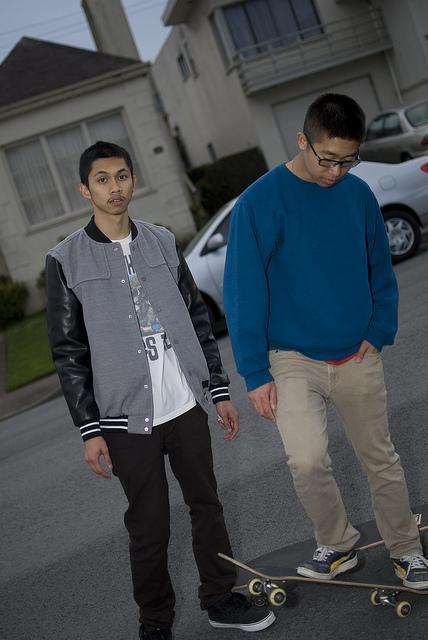How many cars are there?
Give a very brief answer. 2. How many children are seen?
Give a very brief answer. 2. How many skateboards can you see?
Give a very brief answer. 2. How many cars can you see?
Give a very brief answer. 2. How many people can you see?
Give a very brief answer. 2. 